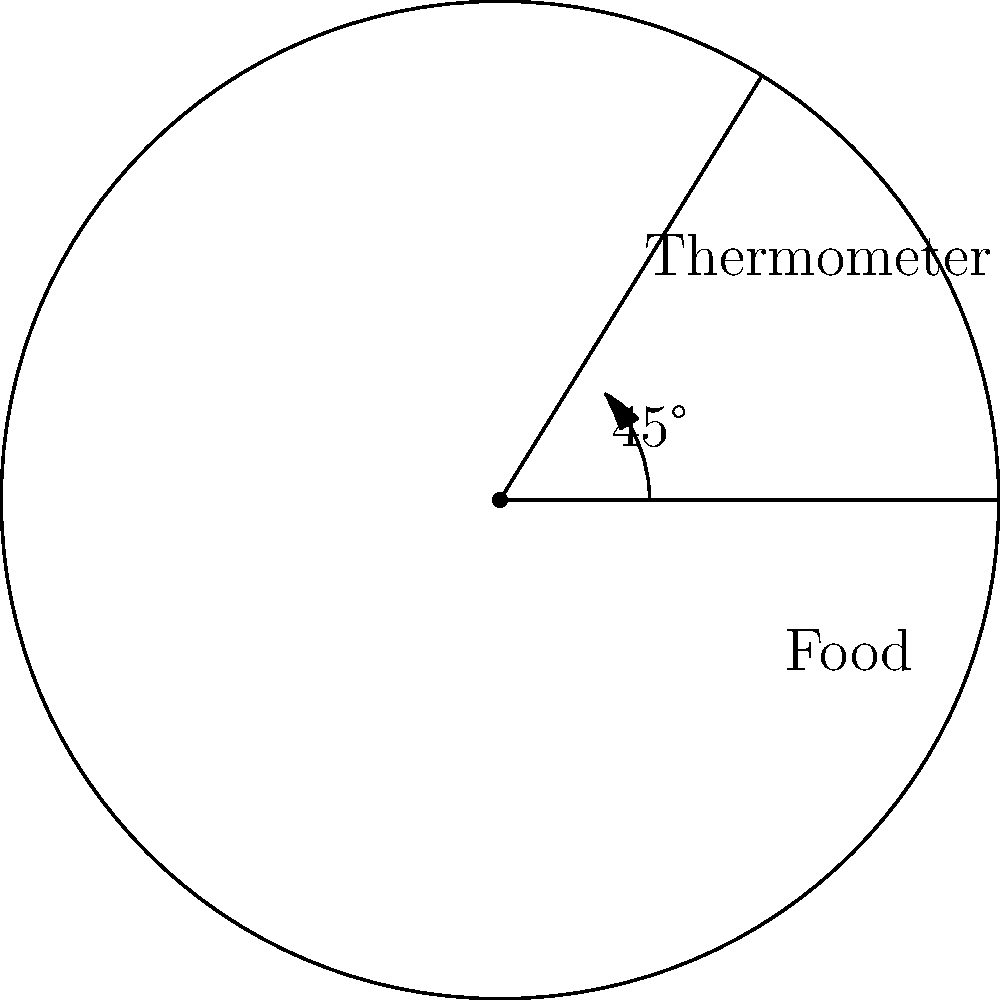When inserting a food thermometer into a dish to measure its internal temperature, at what angle should it be positioned relative to the surface of the food for the most accurate reading? To accurately measure the internal temperature of food using a thermometer, the correct angle of insertion is crucial. Here's why a 45-degree angle is generally recommended:

1. Depth of measurement: A 45-degree angle allows the thermometer probe to reach the center of the food item more easily, especially for thinner cuts of meat or shallow dishes.

2. Avoiding bone or pan: This angle helps prevent the thermometer from touching the bottom of the cooking vessel or hitting a bone in meat, which could lead to inaccurate readings.

3. Sensor positioning: Most food thermometers have their temperature sensor located about 1/2 inch from the tip. The 45-degree angle ensures this part is positioned in the thickest part of the food.

4. Consistency: Using a standard 45-degree angle for all measurements promotes consistency in temperature readings across different food items and among different staff members.

5. Minimal food disruption: This angle allows for easier insertion and removal, minimizing damage to the food's structure and appearance.

6. Quick response: The angled insertion exposes more of the thermometer's sensor to the food's interior, potentially leading to faster and more accurate temperature readings.

Remember, while 45 degrees is generally recommended, the exact angle may vary slightly depending on the specific food item and thermometer design. The key is to ensure the sensing area of the thermometer is fully immersed in the food's center.
Answer: 45 degrees 